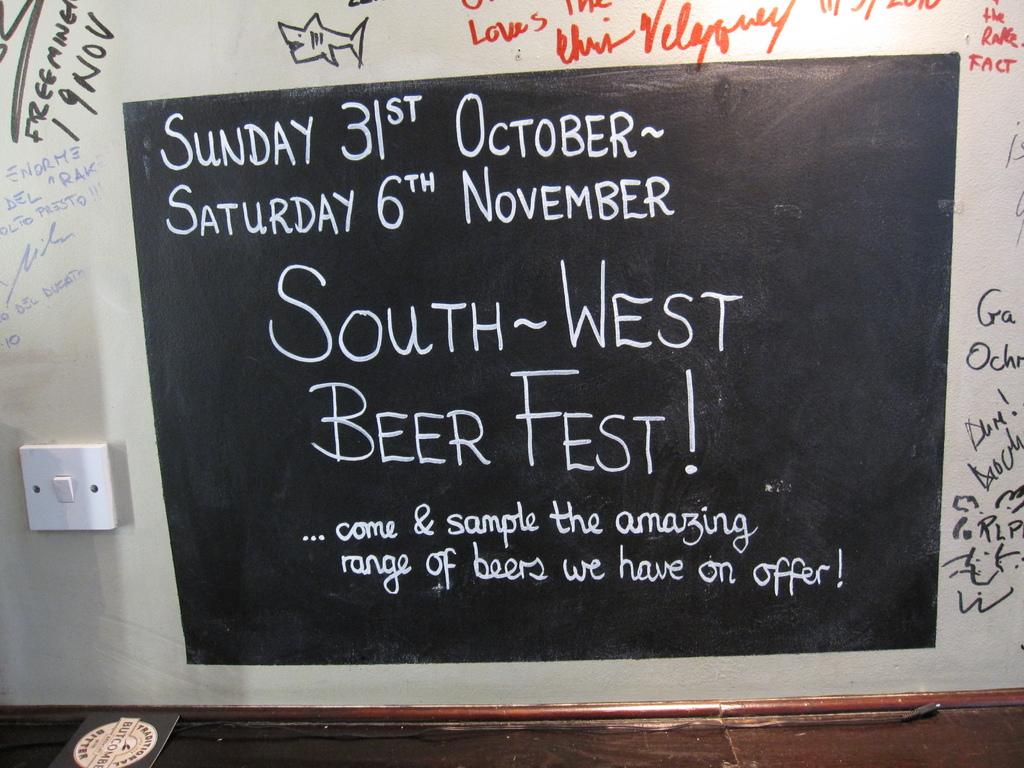What event is advertised?
Ensure brevity in your answer.  South west beer fest. What type of festival is this?
Give a very brief answer. Beer. 